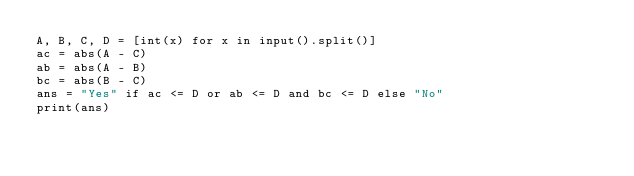<code> <loc_0><loc_0><loc_500><loc_500><_Python_>A, B, C, D = [int(x) for x in input().split()]
ac = abs(A - C)
ab = abs(A - B)
bc = abs(B - C)
ans = "Yes" if ac <= D or ab <= D and bc <= D else "No"
print(ans) </code> 